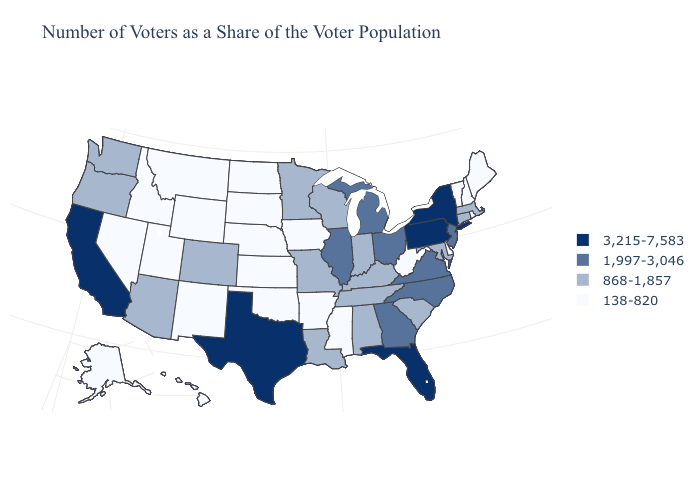Name the states that have a value in the range 138-820?
Short answer required. Alaska, Arkansas, Delaware, Hawaii, Idaho, Iowa, Kansas, Maine, Mississippi, Montana, Nebraska, Nevada, New Hampshire, New Mexico, North Dakota, Oklahoma, Rhode Island, South Dakota, Utah, Vermont, West Virginia, Wyoming. Name the states that have a value in the range 1,997-3,046?
Give a very brief answer. Georgia, Illinois, Michigan, New Jersey, North Carolina, Ohio, Virginia. Does New York have the highest value in the Northeast?
Quick response, please. Yes. Does the map have missing data?
Be succinct. No. Which states have the highest value in the USA?
Quick response, please. California, Florida, New York, Pennsylvania, Texas. What is the highest value in the West ?
Quick response, please. 3,215-7,583. Does Arizona have a lower value than Michigan?
Write a very short answer. Yes. What is the highest value in states that border Iowa?
Be succinct. 1,997-3,046. Among the states that border Colorado , which have the highest value?
Concise answer only. Arizona. What is the highest value in the West ?
Answer briefly. 3,215-7,583. What is the highest value in the Northeast ?
Short answer required. 3,215-7,583. Does Oregon have the same value as West Virginia?
Write a very short answer. No. What is the lowest value in the USA?
Short answer required. 138-820. Does the first symbol in the legend represent the smallest category?
Keep it brief. No. Does the first symbol in the legend represent the smallest category?
Short answer required. No. 